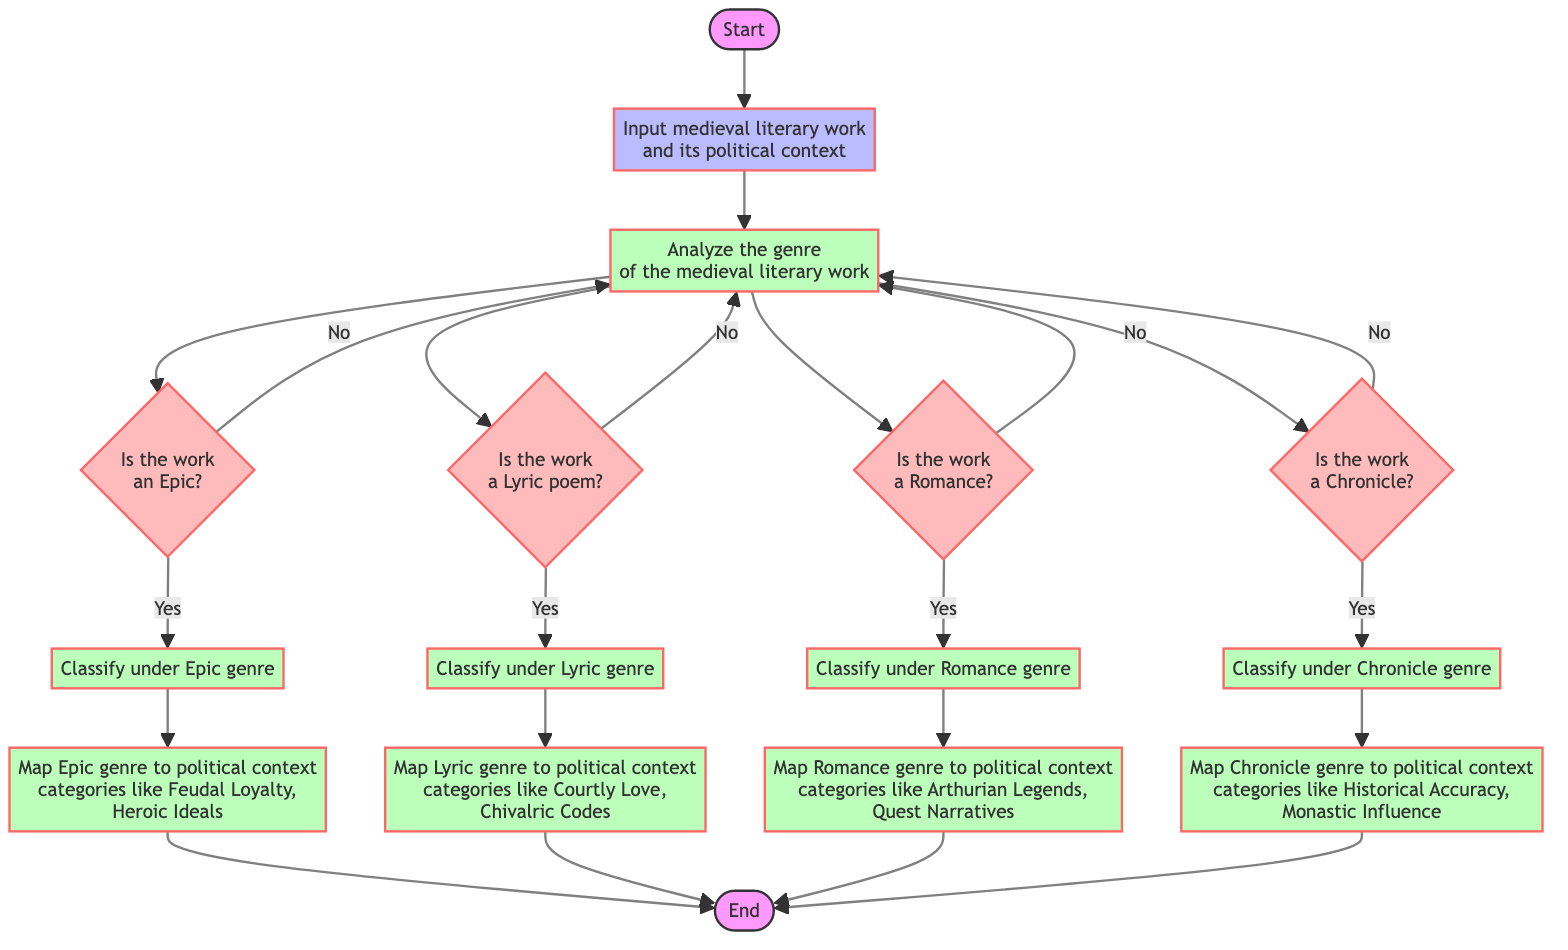What is the first step in the flowchart? The first step in the flowchart is "Initiate categorization process based on the political context," indicated in the Start node.
Answer: Initiate categorization process based on the political context How many genre identification decisions are made in the diagram? The diagram includes four genre identification decisions: Epic, Lyric, Romance, and Chronicle, shown as decision nodes branching from the Analyze node.
Answer: Four What happens if a work is identified as an Epic? If identified as an Epic, it leads to the process of classifying the work under the Epic genre, which is then followed by mapping the Epic genre to relevant political context categories.
Answer: Classify under Epic genre What political context categories does the Epic genre map to? The Epic genre maps to political context categories like Feudal Loyalty and Heroic Ideals, as detailed in the Map_Epic_Context process.
Answer: Feudal Loyalty, Heroic Ideals What is the next step if a work is not classified as a Romance? If a work is not classified as a Romance, the flowchart directs back to the Analyze node to reassess for other genres (Epic, Lyric, Chronicle).
Answer: Analyze genre again Which process immediately follows the identification of a Lyric genre? The process that follows the identification of a Lyric genre is "Map Lyric genre to political context categories like Courtly Love, Chivalric Codes."
Answer: Map Lyric genre to political context categories How many processes are there after the identification nodes? There are four processes following the identification nodes: Classify under Epic, Classify under Lyric, Classify under Romance, and Classify under Chronicle.
Answer: Four What is the final step in the categorization process according to the flowchart? The final step in the categorization process, after mapping any of the genres to their respective contexts, is indicated by the End node.
Answer: Categorization complete 